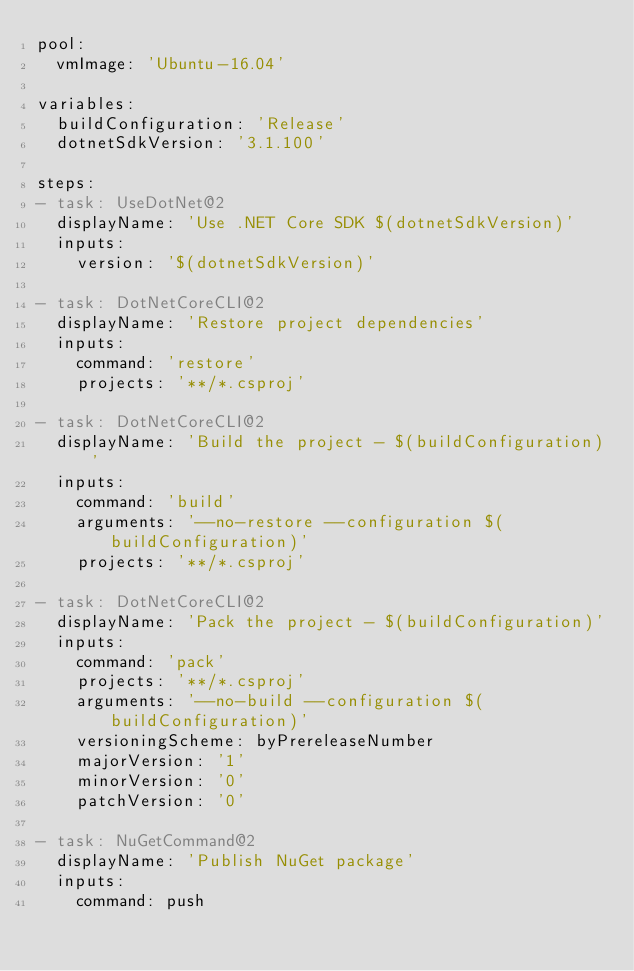<code> <loc_0><loc_0><loc_500><loc_500><_YAML_>pool:
  vmImage: 'Ubuntu-16.04'

variables:
  buildConfiguration: 'Release'
  dotnetSdkVersion: '3.1.100'

steps:
- task: UseDotNet@2
  displayName: 'Use .NET Core SDK $(dotnetSdkVersion)'
  inputs:
    version: '$(dotnetSdkVersion)'

- task: DotNetCoreCLI@2
  displayName: 'Restore project dependencies'
  inputs:
    command: 'restore'
    projects: '**/*.csproj'

- task: DotNetCoreCLI@2
  displayName: 'Build the project - $(buildConfiguration)'
  inputs:
    command: 'build'
    arguments: '--no-restore --configuration $(buildConfiguration)'
    projects: '**/*.csproj'

- task: DotNetCoreCLI@2
  displayName: 'Pack the project - $(buildConfiguration)'
  inputs:
    command: 'pack'
    projects: '**/*.csproj'
    arguments: '--no-build --configuration $(buildConfiguration)'
    versioningScheme: byPrereleaseNumber
    majorVersion: '1'
    minorVersion: '0'
    patchVersion: '0'
 
- task: NuGetCommand@2
  displayName: 'Publish NuGet package'
  inputs:
    command: push</code> 